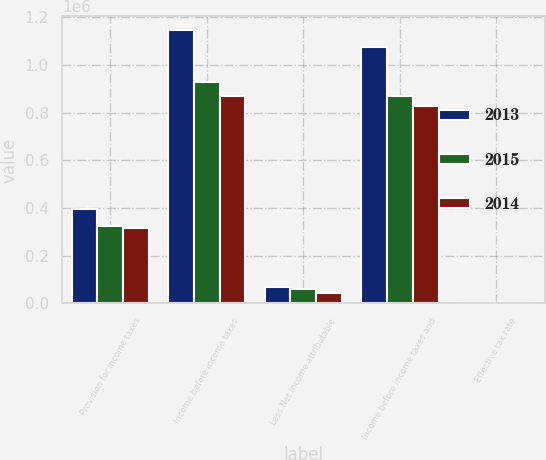Convert chart. <chart><loc_0><loc_0><loc_500><loc_500><stacked_bar_chart><ecel><fcel>Provision for income taxes<fcel>Income before income taxes<fcel>Less Net income attributable<fcel>Income before income taxes and<fcel>Effective tax rate<nl><fcel>2013<fcel>395203<fcel>1.1459e+06<fcel>70170<fcel>1.07573e+06<fcel>36.7<nl><fcel>2015<fcel>324671<fcel>929667<fcel>59653<fcel>870014<fcel>37.3<nl><fcel>2014<fcel>315309<fcel>869332<fcel>43290<fcel>826042<fcel>38.2<nl></chart> 